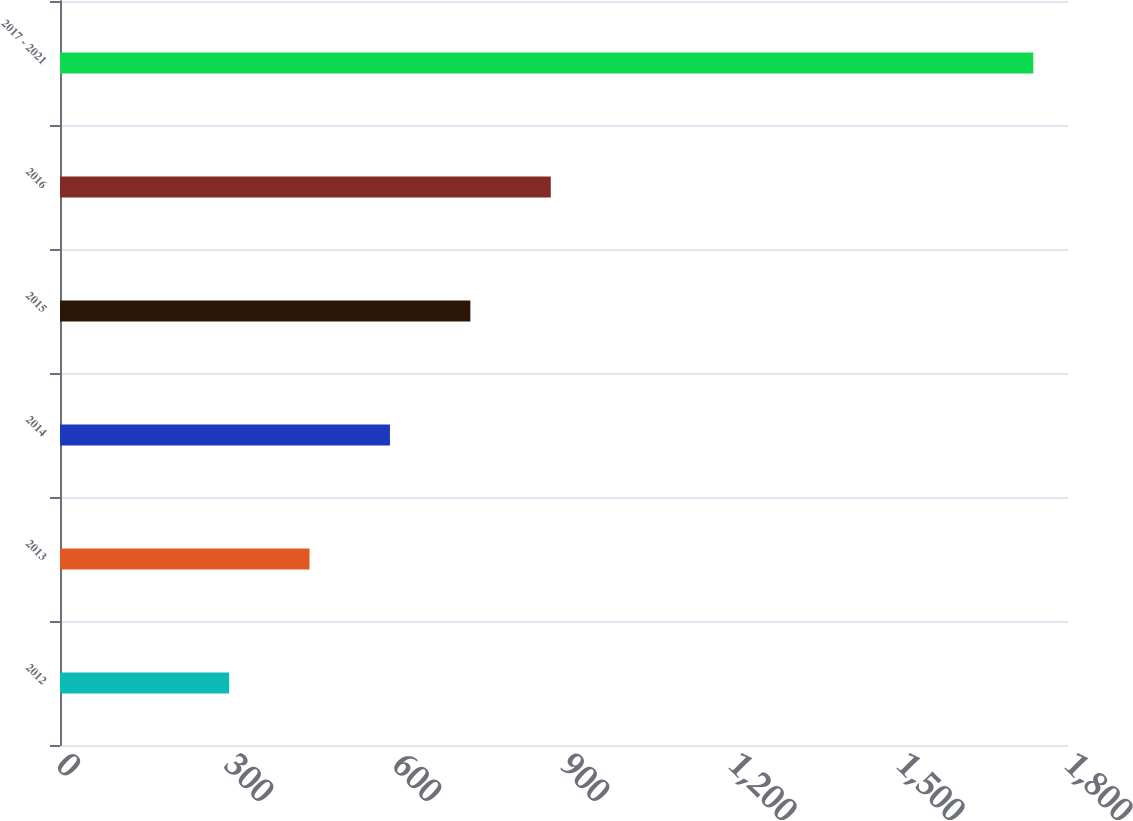Convert chart to OTSL. <chart><loc_0><loc_0><loc_500><loc_500><bar_chart><fcel>2012<fcel>2013<fcel>2014<fcel>2015<fcel>2016<fcel>2017 - 2021<nl><fcel>302<fcel>445.6<fcel>589.2<fcel>732.8<fcel>876.4<fcel>1738<nl></chart> 